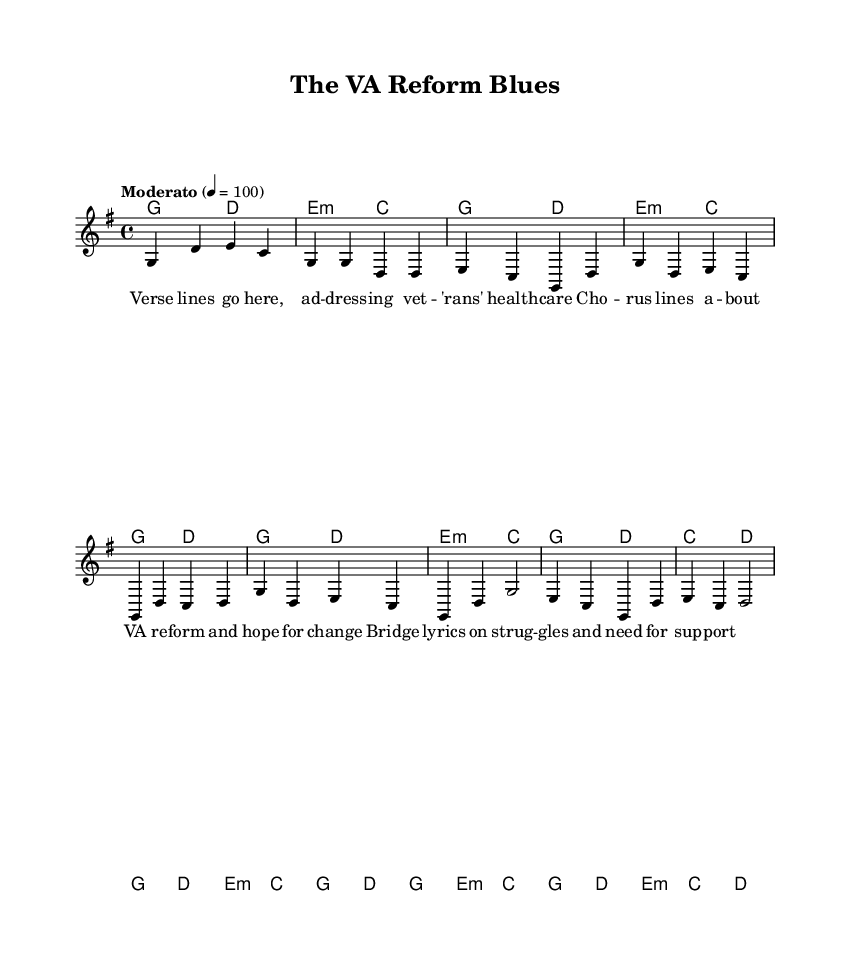What is the key signature of this music? The key signature is G major, which has one sharp. This is indicated at the beginning of the staff.
Answer: G major What is the time signature of this piece? The time signature is 4/4, which means there are four beats in each measure. This is found at the beginning of the sheet music.
Answer: 4/4 What is the tempo marking for this piece? The tempo marking reads "Moderato" with a metronome marking of 100 beats per minute, indicating a moderately paced performance. This can be seen near the top of the sheet music.
Answer: Moderato How many measures are in the chorus? The chorus comprises four measures as indicated by the number of bar lines present. Each measure contains music material contributing to the chorus section.
Answer: 4 What type of song structure is used in this piece? The song follows a typical folk structure with verse, chorus, and bridge sections, which is common in folk music. The labels in the lyrics indicate these parts clearly.
Answer: Verse-Chorus-Bridge What is the function of the bridge in this song? The bridge provides a contrasting section that conveys struggles and the need for support, which adds emotional depth to the song. Lyrics labeled as the bridge indicate this purpose.
Answer: Contrast How does the harmony relate to the melody in the chorus? The harmonies provide the underlying chords that support the melody, with specific chords matched to the lead notes, creating a cohesive sound typical in folk songs. This is shown in the harmonies section corresponding to the melody notes.
Answer: Supportive 